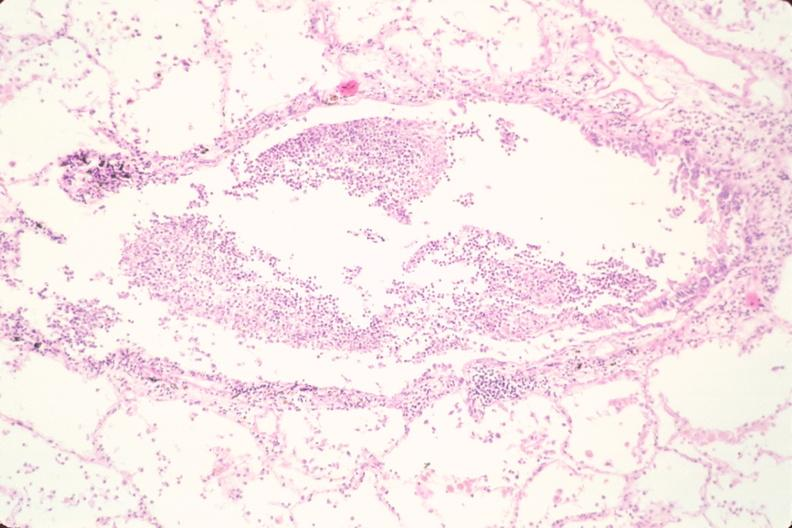what does this image show?
Answer the question using a single word or phrase. Lung 